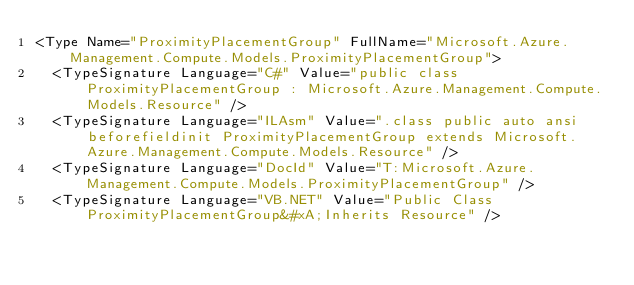<code> <loc_0><loc_0><loc_500><loc_500><_XML_><Type Name="ProximityPlacementGroup" FullName="Microsoft.Azure.Management.Compute.Models.ProximityPlacementGroup">
  <TypeSignature Language="C#" Value="public class ProximityPlacementGroup : Microsoft.Azure.Management.Compute.Models.Resource" />
  <TypeSignature Language="ILAsm" Value=".class public auto ansi beforefieldinit ProximityPlacementGroup extends Microsoft.Azure.Management.Compute.Models.Resource" />
  <TypeSignature Language="DocId" Value="T:Microsoft.Azure.Management.Compute.Models.ProximityPlacementGroup" />
  <TypeSignature Language="VB.NET" Value="Public Class ProximityPlacementGroup&#xA;Inherits Resource" /></code> 